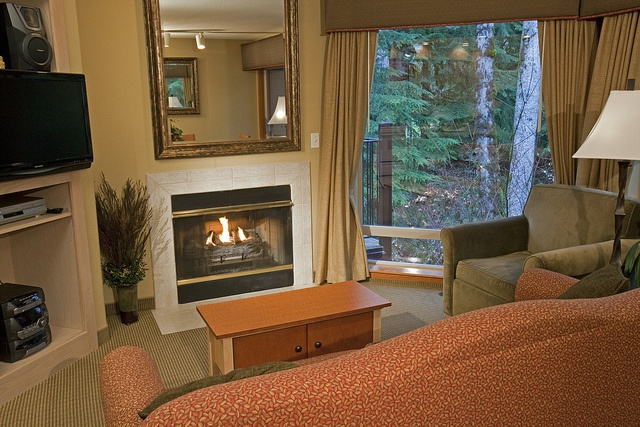Describe the objects in this image and their specific colors. I can see couch in maroon, brown, and salmon tones, couch in maroon, olive, black, and gray tones, tv in maroon, black, olive, and tan tones, potted plant in maroon, black, and olive tones, and vase in black and maroon tones in this image. 